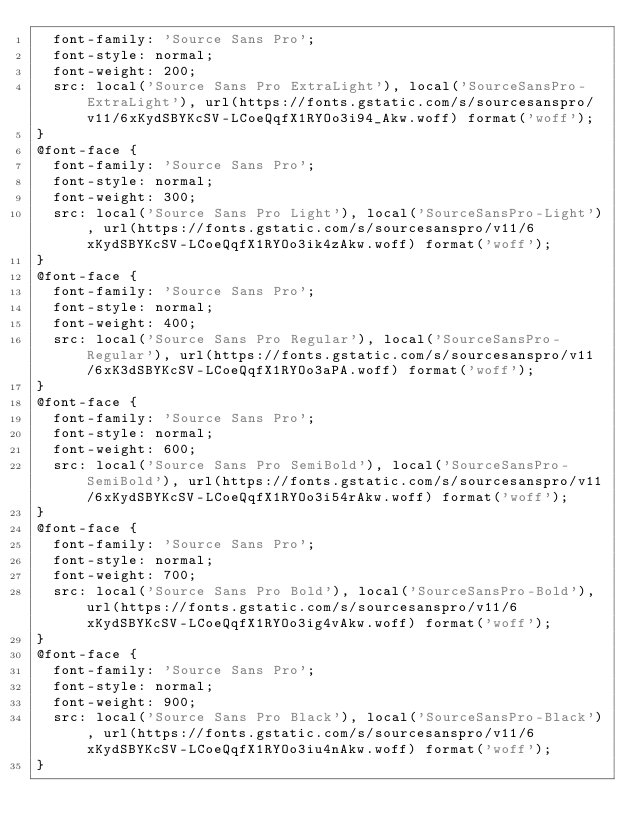Convert code to text. <code><loc_0><loc_0><loc_500><loc_500><_CSS_>  font-family: 'Source Sans Pro';
  font-style: normal;
  font-weight: 200;
  src: local('Source Sans Pro ExtraLight'), local('SourceSansPro-ExtraLight'), url(https://fonts.gstatic.com/s/sourcesanspro/v11/6xKydSBYKcSV-LCoeQqfX1RYOo3i94_Akw.woff) format('woff');
}
@font-face {
  font-family: 'Source Sans Pro';
  font-style: normal;
  font-weight: 300;
  src: local('Source Sans Pro Light'), local('SourceSansPro-Light'), url(https://fonts.gstatic.com/s/sourcesanspro/v11/6xKydSBYKcSV-LCoeQqfX1RYOo3ik4zAkw.woff) format('woff');
}
@font-face {
  font-family: 'Source Sans Pro';
  font-style: normal;
  font-weight: 400;
  src: local('Source Sans Pro Regular'), local('SourceSansPro-Regular'), url(https://fonts.gstatic.com/s/sourcesanspro/v11/6xK3dSBYKcSV-LCoeQqfX1RYOo3aPA.woff) format('woff');
}
@font-face {
  font-family: 'Source Sans Pro';
  font-style: normal;
  font-weight: 600;
  src: local('Source Sans Pro SemiBold'), local('SourceSansPro-SemiBold'), url(https://fonts.gstatic.com/s/sourcesanspro/v11/6xKydSBYKcSV-LCoeQqfX1RYOo3i54rAkw.woff) format('woff');
}
@font-face {
  font-family: 'Source Sans Pro';
  font-style: normal;
  font-weight: 700;
  src: local('Source Sans Pro Bold'), local('SourceSansPro-Bold'), url(https://fonts.gstatic.com/s/sourcesanspro/v11/6xKydSBYKcSV-LCoeQqfX1RYOo3ig4vAkw.woff) format('woff');
}
@font-face {
  font-family: 'Source Sans Pro';
  font-style: normal;
  font-weight: 900;
  src: local('Source Sans Pro Black'), local('SourceSansPro-Black'), url(https://fonts.gstatic.com/s/sourcesanspro/v11/6xKydSBYKcSV-LCoeQqfX1RYOo3iu4nAkw.woff) format('woff');
}
</code> 